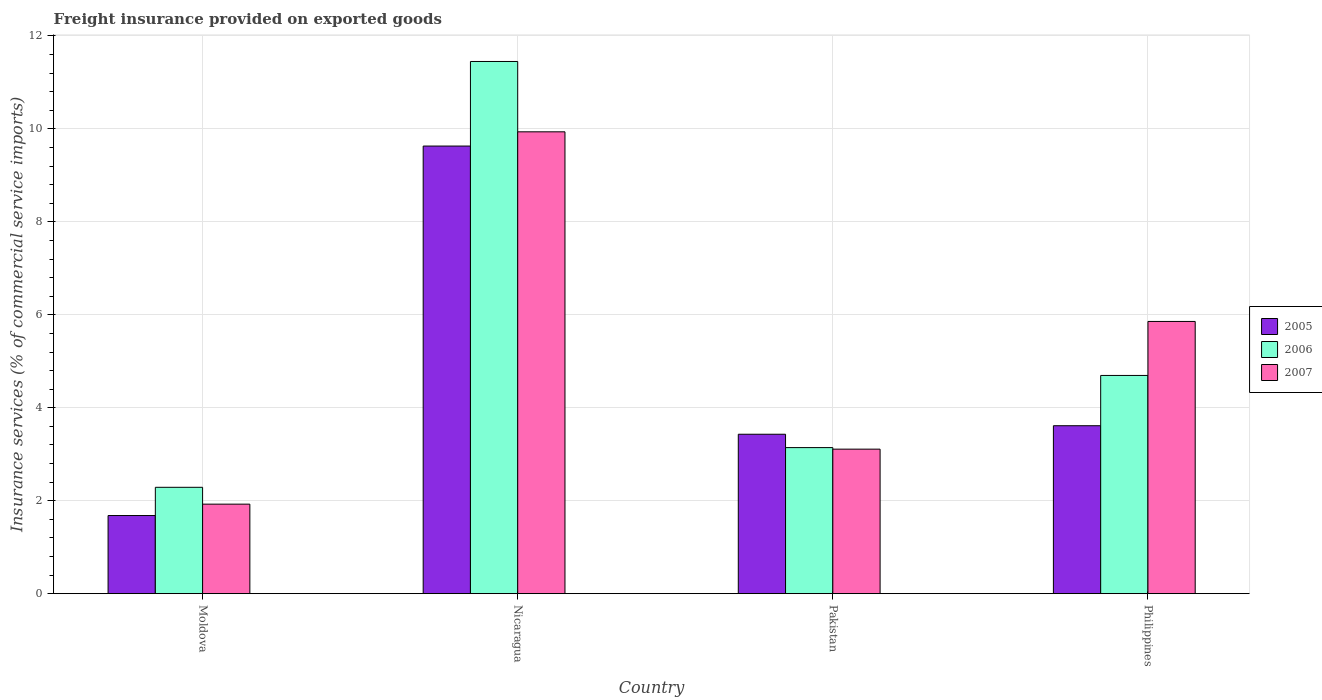How many different coloured bars are there?
Ensure brevity in your answer.  3. How many groups of bars are there?
Your response must be concise. 4. How many bars are there on the 4th tick from the left?
Make the answer very short. 3. What is the label of the 3rd group of bars from the left?
Offer a very short reply. Pakistan. In how many cases, is the number of bars for a given country not equal to the number of legend labels?
Your answer should be compact. 0. What is the freight insurance provided on exported goods in 2007 in Nicaragua?
Ensure brevity in your answer.  9.94. Across all countries, what is the maximum freight insurance provided on exported goods in 2006?
Your answer should be very brief. 11.45. Across all countries, what is the minimum freight insurance provided on exported goods in 2006?
Ensure brevity in your answer.  2.29. In which country was the freight insurance provided on exported goods in 2006 maximum?
Your answer should be very brief. Nicaragua. In which country was the freight insurance provided on exported goods in 2006 minimum?
Offer a terse response. Moldova. What is the total freight insurance provided on exported goods in 2006 in the graph?
Your response must be concise. 21.58. What is the difference between the freight insurance provided on exported goods in 2005 in Nicaragua and that in Pakistan?
Provide a short and direct response. 6.2. What is the difference between the freight insurance provided on exported goods in 2007 in Nicaragua and the freight insurance provided on exported goods in 2006 in Moldova?
Your answer should be very brief. 7.65. What is the average freight insurance provided on exported goods in 2006 per country?
Your answer should be very brief. 5.39. What is the difference between the freight insurance provided on exported goods of/in 2005 and freight insurance provided on exported goods of/in 2007 in Moldova?
Ensure brevity in your answer.  -0.25. What is the ratio of the freight insurance provided on exported goods in 2007 in Moldova to that in Pakistan?
Provide a succinct answer. 0.62. What is the difference between the highest and the second highest freight insurance provided on exported goods in 2005?
Give a very brief answer. -6.2. What is the difference between the highest and the lowest freight insurance provided on exported goods in 2007?
Offer a very short reply. 8.01. In how many countries, is the freight insurance provided on exported goods in 2005 greater than the average freight insurance provided on exported goods in 2005 taken over all countries?
Provide a succinct answer. 1. What does the 2nd bar from the left in Pakistan represents?
Keep it short and to the point. 2006. Is it the case that in every country, the sum of the freight insurance provided on exported goods in 2007 and freight insurance provided on exported goods in 2005 is greater than the freight insurance provided on exported goods in 2006?
Make the answer very short. Yes. How many bars are there?
Your response must be concise. 12. What is the difference between two consecutive major ticks on the Y-axis?
Provide a short and direct response. 2. Are the values on the major ticks of Y-axis written in scientific E-notation?
Offer a terse response. No. Does the graph contain any zero values?
Ensure brevity in your answer.  No. Does the graph contain grids?
Offer a very short reply. Yes. What is the title of the graph?
Your response must be concise. Freight insurance provided on exported goods. What is the label or title of the Y-axis?
Keep it short and to the point. Insurance services (% of commercial service imports). What is the Insurance services (% of commercial service imports) in 2005 in Moldova?
Offer a terse response. 1.68. What is the Insurance services (% of commercial service imports) of 2006 in Moldova?
Keep it short and to the point. 2.29. What is the Insurance services (% of commercial service imports) of 2007 in Moldova?
Your answer should be very brief. 1.93. What is the Insurance services (% of commercial service imports) in 2005 in Nicaragua?
Your answer should be very brief. 9.63. What is the Insurance services (% of commercial service imports) in 2006 in Nicaragua?
Ensure brevity in your answer.  11.45. What is the Insurance services (% of commercial service imports) of 2007 in Nicaragua?
Your response must be concise. 9.94. What is the Insurance services (% of commercial service imports) in 2005 in Pakistan?
Offer a terse response. 3.43. What is the Insurance services (% of commercial service imports) in 2006 in Pakistan?
Offer a terse response. 3.14. What is the Insurance services (% of commercial service imports) in 2007 in Pakistan?
Keep it short and to the point. 3.11. What is the Insurance services (% of commercial service imports) in 2005 in Philippines?
Your response must be concise. 3.61. What is the Insurance services (% of commercial service imports) in 2006 in Philippines?
Your answer should be compact. 4.7. What is the Insurance services (% of commercial service imports) in 2007 in Philippines?
Your response must be concise. 5.86. Across all countries, what is the maximum Insurance services (% of commercial service imports) of 2005?
Your response must be concise. 9.63. Across all countries, what is the maximum Insurance services (% of commercial service imports) of 2006?
Ensure brevity in your answer.  11.45. Across all countries, what is the maximum Insurance services (% of commercial service imports) in 2007?
Provide a succinct answer. 9.94. Across all countries, what is the minimum Insurance services (% of commercial service imports) in 2005?
Your answer should be compact. 1.68. Across all countries, what is the minimum Insurance services (% of commercial service imports) in 2006?
Provide a succinct answer. 2.29. Across all countries, what is the minimum Insurance services (% of commercial service imports) in 2007?
Your answer should be compact. 1.93. What is the total Insurance services (% of commercial service imports) in 2005 in the graph?
Offer a terse response. 18.36. What is the total Insurance services (% of commercial service imports) of 2006 in the graph?
Provide a short and direct response. 21.58. What is the total Insurance services (% of commercial service imports) in 2007 in the graph?
Your response must be concise. 20.83. What is the difference between the Insurance services (% of commercial service imports) in 2005 in Moldova and that in Nicaragua?
Provide a succinct answer. -7.95. What is the difference between the Insurance services (% of commercial service imports) in 2006 in Moldova and that in Nicaragua?
Provide a short and direct response. -9.16. What is the difference between the Insurance services (% of commercial service imports) in 2007 in Moldova and that in Nicaragua?
Offer a terse response. -8.01. What is the difference between the Insurance services (% of commercial service imports) of 2005 in Moldova and that in Pakistan?
Make the answer very short. -1.75. What is the difference between the Insurance services (% of commercial service imports) of 2006 in Moldova and that in Pakistan?
Ensure brevity in your answer.  -0.85. What is the difference between the Insurance services (% of commercial service imports) of 2007 in Moldova and that in Pakistan?
Your answer should be very brief. -1.18. What is the difference between the Insurance services (% of commercial service imports) in 2005 in Moldova and that in Philippines?
Keep it short and to the point. -1.93. What is the difference between the Insurance services (% of commercial service imports) in 2006 in Moldova and that in Philippines?
Provide a short and direct response. -2.41. What is the difference between the Insurance services (% of commercial service imports) of 2007 in Moldova and that in Philippines?
Provide a short and direct response. -3.93. What is the difference between the Insurance services (% of commercial service imports) of 2005 in Nicaragua and that in Pakistan?
Make the answer very short. 6.2. What is the difference between the Insurance services (% of commercial service imports) in 2006 in Nicaragua and that in Pakistan?
Ensure brevity in your answer.  8.31. What is the difference between the Insurance services (% of commercial service imports) in 2007 in Nicaragua and that in Pakistan?
Your answer should be very brief. 6.83. What is the difference between the Insurance services (% of commercial service imports) of 2005 in Nicaragua and that in Philippines?
Make the answer very short. 6.02. What is the difference between the Insurance services (% of commercial service imports) of 2006 in Nicaragua and that in Philippines?
Offer a very short reply. 6.76. What is the difference between the Insurance services (% of commercial service imports) of 2007 in Nicaragua and that in Philippines?
Offer a terse response. 4.08. What is the difference between the Insurance services (% of commercial service imports) of 2005 in Pakistan and that in Philippines?
Your answer should be very brief. -0.18. What is the difference between the Insurance services (% of commercial service imports) in 2006 in Pakistan and that in Philippines?
Your answer should be compact. -1.55. What is the difference between the Insurance services (% of commercial service imports) of 2007 in Pakistan and that in Philippines?
Ensure brevity in your answer.  -2.75. What is the difference between the Insurance services (% of commercial service imports) in 2005 in Moldova and the Insurance services (% of commercial service imports) in 2006 in Nicaragua?
Give a very brief answer. -9.77. What is the difference between the Insurance services (% of commercial service imports) of 2005 in Moldova and the Insurance services (% of commercial service imports) of 2007 in Nicaragua?
Make the answer very short. -8.26. What is the difference between the Insurance services (% of commercial service imports) in 2006 in Moldova and the Insurance services (% of commercial service imports) in 2007 in Nicaragua?
Your answer should be very brief. -7.65. What is the difference between the Insurance services (% of commercial service imports) of 2005 in Moldova and the Insurance services (% of commercial service imports) of 2006 in Pakistan?
Your answer should be compact. -1.46. What is the difference between the Insurance services (% of commercial service imports) in 2005 in Moldova and the Insurance services (% of commercial service imports) in 2007 in Pakistan?
Give a very brief answer. -1.43. What is the difference between the Insurance services (% of commercial service imports) in 2006 in Moldova and the Insurance services (% of commercial service imports) in 2007 in Pakistan?
Keep it short and to the point. -0.82. What is the difference between the Insurance services (% of commercial service imports) of 2005 in Moldova and the Insurance services (% of commercial service imports) of 2006 in Philippines?
Keep it short and to the point. -3.01. What is the difference between the Insurance services (% of commercial service imports) of 2005 in Moldova and the Insurance services (% of commercial service imports) of 2007 in Philippines?
Your answer should be very brief. -4.18. What is the difference between the Insurance services (% of commercial service imports) in 2006 in Moldova and the Insurance services (% of commercial service imports) in 2007 in Philippines?
Your answer should be compact. -3.57. What is the difference between the Insurance services (% of commercial service imports) of 2005 in Nicaragua and the Insurance services (% of commercial service imports) of 2006 in Pakistan?
Keep it short and to the point. 6.49. What is the difference between the Insurance services (% of commercial service imports) of 2005 in Nicaragua and the Insurance services (% of commercial service imports) of 2007 in Pakistan?
Make the answer very short. 6.52. What is the difference between the Insurance services (% of commercial service imports) in 2006 in Nicaragua and the Insurance services (% of commercial service imports) in 2007 in Pakistan?
Make the answer very short. 8.34. What is the difference between the Insurance services (% of commercial service imports) of 2005 in Nicaragua and the Insurance services (% of commercial service imports) of 2006 in Philippines?
Make the answer very short. 4.94. What is the difference between the Insurance services (% of commercial service imports) in 2005 in Nicaragua and the Insurance services (% of commercial service imports) in 2007 in Philippines?
Ensure brevity in your answer.  3.77. What is the difference between the Insurance services (% of commercial service imports) in 2006 in Nicaragua and the Insurance services (% of commercial service imports) in 2007 in Philippines?
Your answer should be compact. 5.59. What is the difference between the Insurance services (% of commercial service imports) in 2005 in Pakistan and the Insurance services (% of commercial service imports) in 2006 in Philippines?
Your answer should be very brief. -1.27. What is the difference between the Insurance services (% of commercial service imports) in 2005 in Pakistan and the Insurance services (% of commercial service imports) in 2007 in Philippines?
Make the answer very short. -2.43. What is the difference between the Insurance services (% of commercial service imports) in 2006 in Pakistan and the Insurance services (% of commercial service imports) in 2007 in Philippines?
Ensure brevity in your answer.  -2.71. What is the average Insurance services (% of commercial service imports) of 2005 per country?
Give a very brief answer. 4.59. What is the average Insurance services (% of commercial service imports) in 2006 per country?
Your response must be concise. 5.39. What is the average Insurance services (% of commercial service imports) of 2007 per country?
Make the answer very short. 5.21. What is the difference between the Insurance services (% of commercial service imports) in 2005 and Insurance services (% of commercial service imports) in 2006 in Moldova?
Make the answer very short. -0.61. What is the difference between the Insurance services (% of commercial service imports) of 2005 and Insurance services (% of commercial service imports) of 2007 in Moldova?
Keep it short and to the point. -0.25. What is the difference between the Insurance services (% of commercial service imports) in 2006 and Insurance services (% of commercial service imports) in 2007 in Moldova?
Offer a terse response. 0.36. What is the difference between the Insurance services (% of commercial service imports) of 2005 and Insurance services (% of commercial service imports) of 2006 in Nicaragua?
Keep it short and to the point. -1.82. What is the difference between the Insurance services (% of commercial service imports) of 2005 and Insurance services (% of commercial service imports) of 2007 in Nicaragua?
Keep it short and to the point. -0.31. What is the difference between the Insurance services (% of commercial service imports) of 2006 and Insurance services (% of commercial service imports) of 2007 in Nicaragua?
Your answer should be compact. 1.51. What is the difference between the Insurance services (% of commercial service imports) of 2005 and Insurance services (% of commercial service imports) of 2006 in Pakistan?
Provide a short and direct response. 0.29. What is the difference between the Insurance services (% of commercial service imports) in 2005 and Insurance services (% of commercial service imports) in 2007 in Pakistan?
Offer a very short reply. 0.32. What is the difference between the Insurance services (% of commercial service imports) of 2006 and Insurance services (% of commercial service imports) of 2007 in Pakistan?
Make the answer very short. 0.03. What is the difference between the Insurance services (% of commercial service imports) of 2005 and Insurance services (% of commercial service imports) of 2006 in Philippines?
Your answer should be compact. -1.08. What is the difference between the Insurance services (% of commercial service imports) of 2005 and Insurance services (% of commercial service imports) of 2007 in Philippines?
Keep it short and to the point. -2.24. What is the difference between the Insurance services (% of commercial service imports) of 2006 and Insurance services (% of commercial service imports) of 2007 in Philippines?
Give a very brief answer. -1.16. What is the ratio of the Insurance services (% of commercial service imports) in 2005 in Moldova to that in Nicaragua?
Make the answer very short. 0.17. What is the ratio of the Insurance services (% of commercial service imports) of 2006 in Moldova to that in Nicaragua?
Your answer should be very brief. 0.2. What is the ratio of the Insurance services (% of commercial service imports) of 2007 in Moldova to that in Nicaragua?
Provide a succinct answer. 0.19. What is the ratio of the Insurance services (% of commercial service imports) of 2005 in Moldova to that in Pakistan?
Offer a terse response. 0.49. What is the ratio of the Insurance services (% of commercial service imports) in 2006 in Moldova to that in Pakistan?
Offer a terse response. 0.73. What is the ratio of the Insurance services (% of commercial service imports) in 2007 in Moldova to that in Pakistan?
Provide a short and direct response. 0.62. What is the ratio of the Insurance services (% of commercial service imports) of 2005 in Moldova to that in Philippines?
Provide a succinct answer. 0.47. What is the ratio of the Insurance services (% of commercial service imports) of 2006 in Moldova to that in Philippines?
Your answer should be very brief. 0.49. What is the ratio of the Insurance services (% of commercial service imports) of 2007 in Moldova to that in Philippines?
Keep it short and to the point. 0.33. What is the ratio of the Insurance services (% of commercial service imports) in 2005 in Nicaragua to that in Pakistan?
Your answer should be very brief. 2.81. What is the ratio of the Insurance services (% of commercial service imports) of 2006 in Nicaragua to that in Pakistan?
Provide a succinct answer. 3.64. What is the ratio of the Insurance services (% of commercial service imports) in 2007 in Nicaragua to that in Pakistan?
Your answer should be very brief. 3.2. What is the ratio of the Insurance services (% of commercial service imports) of 2005 in Nicaragua to that in Philippines?
Offer a terse response. 2.67. What is the ratio of the Insurance services (% of commercial service imports) of 2006 in Nicaragua to that in Philippines?
Provide a short and direct response. 2.44. What is the ratio of the Insurance services (% of commercial service imports) in 2007 in Nicaragua to that in Philippines?
Provide a short and direct response. 1.7. What is the ratio of the Insurance services (% of commercial service imports) in 2005 in Pakistan to that in Philippines?
Ensure brevity in your answer.  0.95. What is the ratio of the Insurance services (% of commercial service imports) in 2006 in Pakistan to that in Philippines?
Your answer should be compact. 0.67. What is the ratio of the Insurance services (% of commercial service imports) of 2007 in Pakistan to that in Philippines?
Give a very brief answer. 0.53. What is the difference between the highest and the second highest Insurance services (% of commercial service imports) in 2005?
Your answer should be compact. 6.02. What is the difference between the highest and the second highest Insurance services (% of commercial service imports) of 2006?
Offer a terse response. 6.76. What is the difference between the highest and the second highest Insurance services (% of commercial service imports) of 2007?
Make the answer very short. 4.08. What is the difference between the highest and the lowest Insurance services (% of commercial service imports) of 2005?
Your response must be concise. 7.95. What is the difference between the highest and the lowest Insurance services (% of commercial service imports) of 2006?
Offer a very short reply. 9.16. What is the difference between the highest and the lowest Insurance services (% of commercial service imports) of 2007?
Provide a succinct answer. 8.01. 